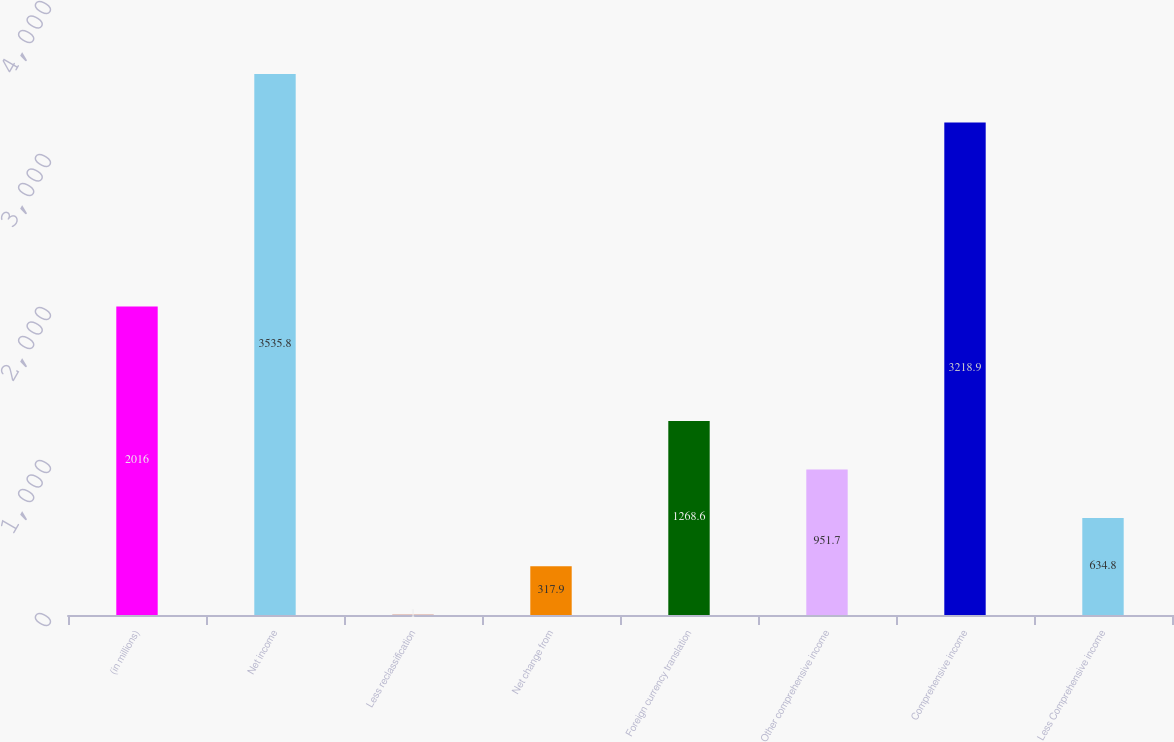Convert chart to OTSL. <chart><loc_0><loc_0><loc_500><loc_500><bar_chart><fcel>(in millions)<fcel>Net income<fcel>Less reclassification<fcel>Net change from<fcel>Foreign currency translation<fcel>Other comprehensive income<fcel>Comprehensive income<fcel>Less Comprehensive income<nl><fcel>2016<fcel>3535.8<fcel>1<fcel>317.9<fcel>1268.6<fcel>951.7<fcel>3218.9<fcel>634.8<nl></chart> 